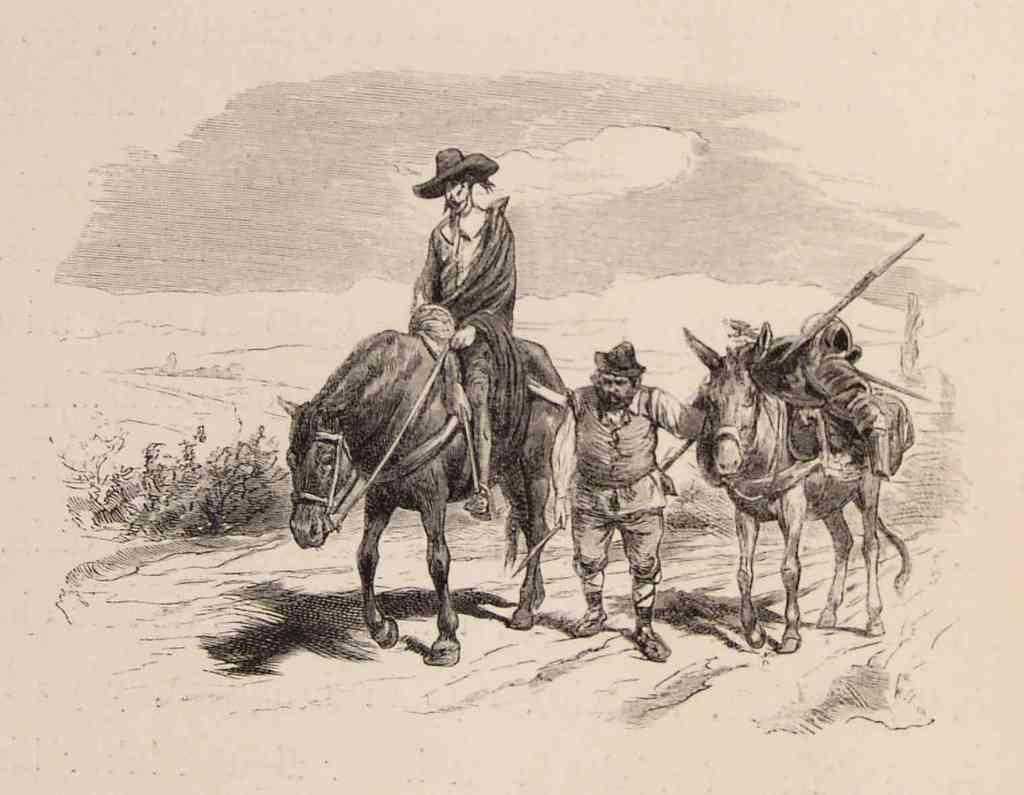What is the main subject of the image? There is an art piece in the image. What animals are featured in the art piece? The art piece contains horses. What other subjects are depicted in the art piece? The art piece contains people. How many spiders can be seen weaving a web in the image? There are no spiders present in the image. What scientific principles are being demonstrated in the image? The image does not depict any scientific principles; it is an art piece featuring horses and people. 